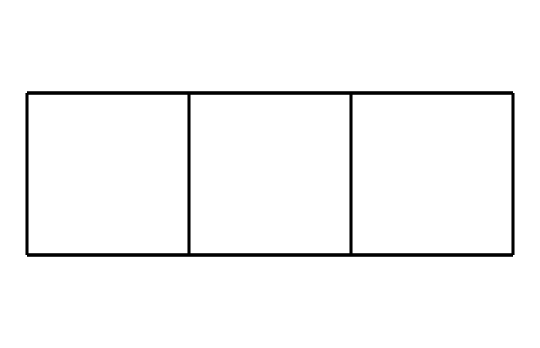What is the molecular formula of cubane? The SMILES representation indicates a structure with 8 carbon atoms and 8 hydrogen atoms, leading to the molecular formula C8H8.
Answer: C8H8 How many carbon atoms does cubane have? By analyzing the SMILES representation, we can count a total of 8 carbon symbols (C), which indicates the number of carbon atoms present.
Answer: 8 What geometric type does cubane represent? The structure depicted shows a highly symmetrical three-dimensional arrangement, specifically a cubic geometry, characteristic of cubane.
Answer: cubic How many hydrogen atoms are in cubane? The SMILES representation shows that for every carbon atom in cubane, 2 hydrogen atoms are bonded, totaling to 8 hydrogen atoms.
Answer: 8 What is the bond angle in cubane? The highly symmetrical structure suggests that the carbon-carbon bonds form 90-degree angles, typical of a cube arrangement.
Answer: 90 degrees Does cubane exhibit any flexibility? The rigidity of the cubane structure, characterized by its fixed geometric form, is a defining feature, indicating no flexibility in the molecular architecture.
Answer: No Is cubane a saturated or unsaturated hydrocarbon? The structure contains only single bonds between all carbon atoms, confirming that it is a saturated hydrocarbon.
Answer: saturated 